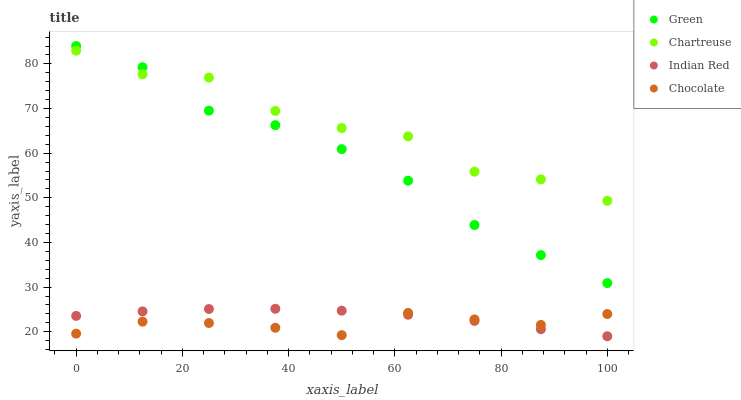Does Chocolate have the minimum area under the curve?
Answer yes or no. Yes. Does Chartreuse have the maximum area under the curve?
Answer yes or no. Yes. Does Green have the minimum area under the curve?
Answer yes or no. No. Does Green have the maximum area under the curve?
Answer yes or no. No. Is Indian Red the smoothest?
Answer yes or no. Yes. Is Chartreuse the roughest?
Answer yes or no. Yes. Is Green the smoothest?
Answer yes or no. No. Is Green the roughest?
Answer yes or no. No. Does Indian Red have the lowest value?
Answer yes or no. Yes. Does Green have the lowest value?
Answer yes or no. No. Does Green have the highest value?
Answer yes or no. Yes. Does Indian Red have the highest value?
Answer yes or no. No. Is Chocolate less than Chartreuse?
Answer yes or no. Yes. Is Chartreuse greater than Indian Red?
Answer yes or no. Yes. Does Chocolate intersect Indian Red?
Answer yes or no. Yes. Is Chocolate less than Indian Red?
Answer yes or no. No. Is Chocolate greater than Indian Red?
Answer yes or no. No. Does Chocolate intersect Chartreuse?
Answer yes or no. No. 